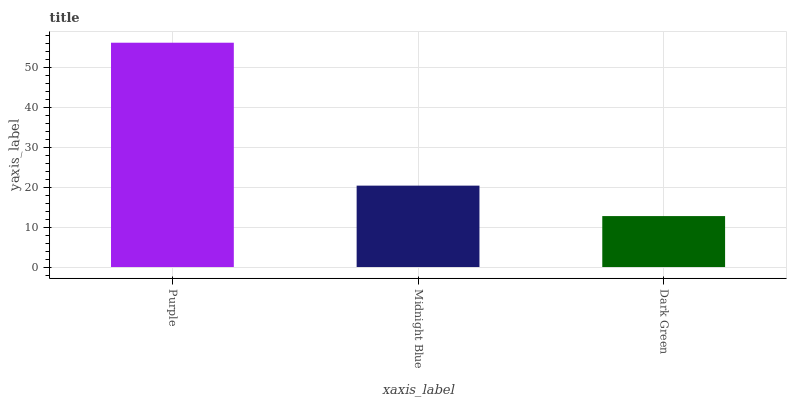Is Dark Green the minimum?
Answer yes or no. Yes. Is Purple the maximum?
Answer yes or no. Yes. Is Midnight Blue the minimum?
Answer yes or no. No. Is Midnight Blue the maximum?
Answer yes or no. No. Is Purple greater than Midnight Blue?
Answer yes or no. Yes. Is Midnight Blue less than Purple?
Answer yes or no. Yes. Is Midnight Blue greater than Purple?
Answer yes or no. No. Is Purple less than Midnight Blue?
Answer yes or no. No. Is Midnight Blue the high median?
Answer yes or no. Yes. Is Midnight Blue the low median?
Answer yes or no. Yes. Is Purple the high median?
Answer yes or no. No. Is Purple the low median?
Answer yes or no. No. 